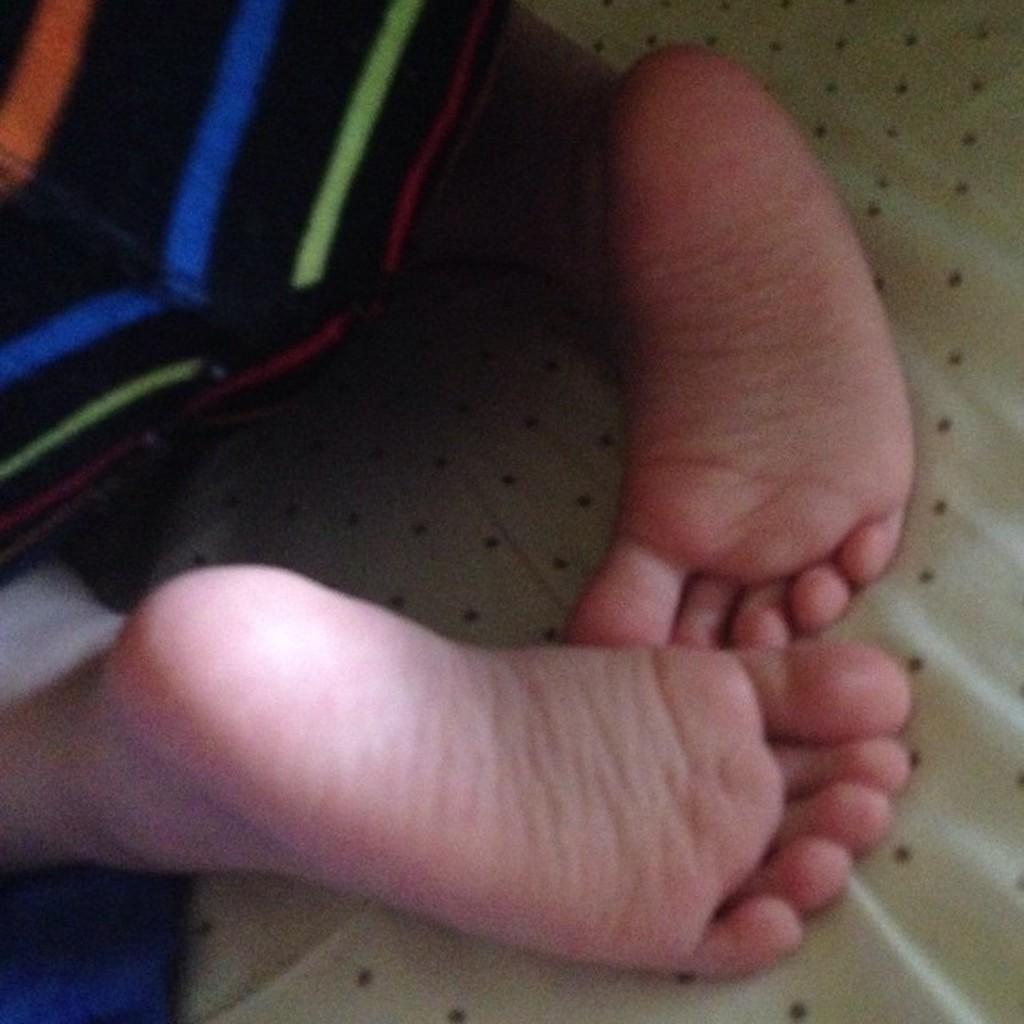How would you summarize this image in a sentence or two? In this image we can see two legs of a baby laying on the cloth. 